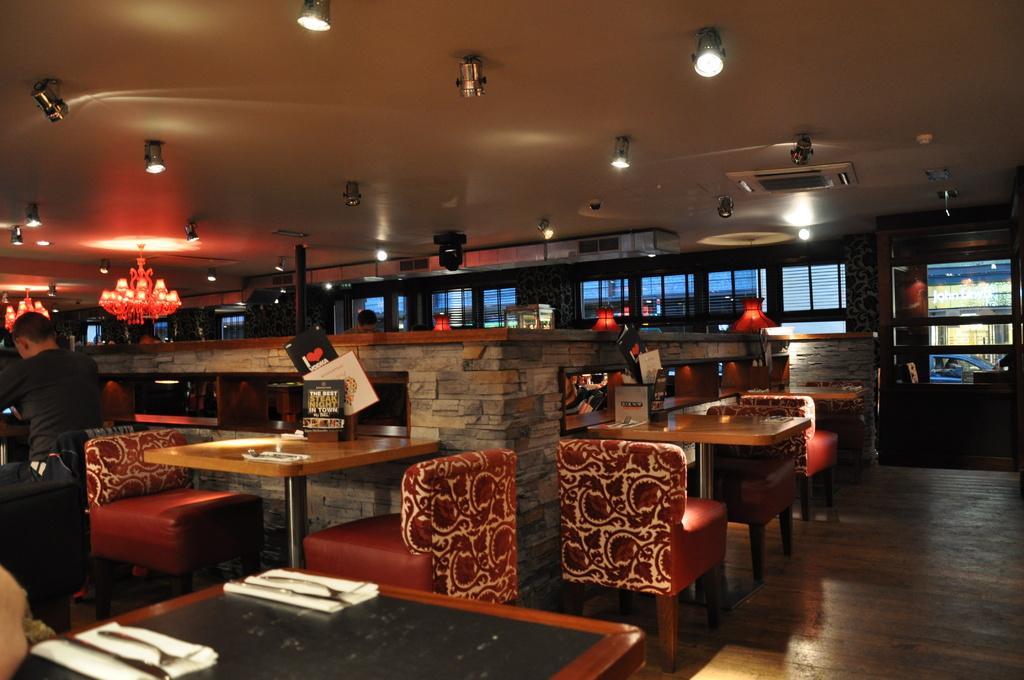Please provide a concise description of this image. In this image there are tables and there are empty chairs. On the left side there is a person sitting on the chair. In the background there are chandeliers hanging there are lights and there are windows and behind the window there is a car which is blue in colour and there is a person standing in the background. In the front on the table there are napkins and there are spoons. 